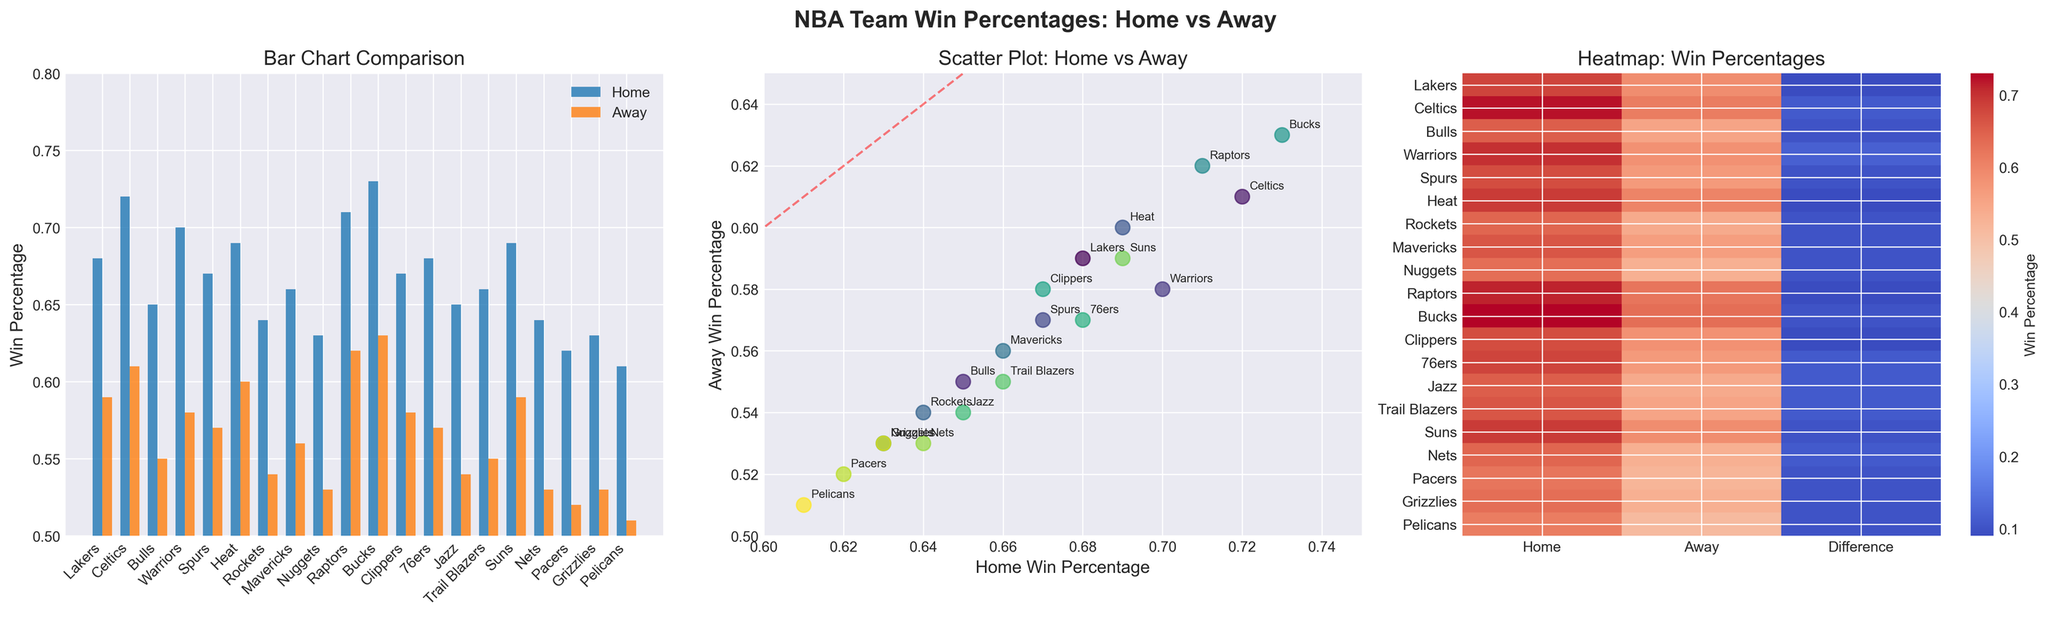What is the average home win percentage of all teams? To find the average home win percentage, sum all the home win percentages and divide by the number of teams. (0.68 + 0.72 + 0.65 + 0.70 + 0.67 + 0.69 + 0.64 + 0.66 + 0.63 + 0.71 + 0.73 + 0.67 + 0.68 + 0.65 + 0.66 + 0.69 + 0.64 + 0.62 + 0.63 + 0.61) / 20 = 13.04 / 20 = 0.652
Answer: 0.652 Which team has the smallest difference between home and away win percentages? From the heatmap subplot, the difference between home and away win percentages is visually represented. Observing this, the smallest difference can be seen for the Heat and Spurs, both having small bars in the "Difference" column.
Answer: Heat and Spurs Are there any teams with home win percentages less than 0.65? Check the bar chart subplot for any bars representing home win percentages that fall below the mark of 0.65. Identify and confirm the corresponding team labels. The teams with home win percentages less than 0.65 are the Rockets, Mavericks, Nuggets, Nets, Pacers, Grizzlies, and Pelicans.
Answer: Yes How many teams have a higher away win percentage than the Clippers' home win percentage? The Clippers' home win percentage is 0.67. Compare this value to the away win percentages in the bar chart subplot. The teams with away win percentages higher than 0.67 are the Bucks and Raptors.
Answer: 2 Which team has the highest difference between home and away win percentages? From the heatmap subplot, identify the team row with the largest color intensity difference between "Home" and "Away". The metric difference is noticeably high for the Bucks and Raptors.
Answer: Bucks and Raptors Which two teams have the closest home win percentages? In the bar chart subplot, identify the home win percentages that are closely clustered together. The closest values appear to be those of the Clippers and 76ers, both at 0.67.
Answer: Clippers and 76ers What percentage range do most away win percentages fall into? Observing the bar chart and scatter plot subplots, estimate the majority of the away win percentages. Most away win percentages fall between 0.55 and 0.60.
Answer: 0.55 - 0.60 Which team ranks last in home win percentage and what is its value? Check the bar chart subplot and find the smallest bar in the home win percentage category. The Pelicans have the lowest home win percentage of 0.61.
Answer: Pelicans, 0.61 How do the average home and away win percentages compare? Calculate the average of home win percentages and the average of away win percentages, then compare the two. Average home win percentage: 0.652 (as calculated). Average away win percentage: (0.59 + 0.61 + 0.55 + 0.58 + 0.57 + 0.60 + 0.54 + 0.56 + 0.53 + 0.62 + 0.63 + 0.58 + 0.57 + 0.54 + 0.55 + 0.59 + 0.53 + 0.52 + 0.53 + 0.51) / 20 = 11.77 / 20 = 0.5885. The average home win percentage is higher than the average away win percentage: 0.652 > 0.5885.
Answer: Home > Away 